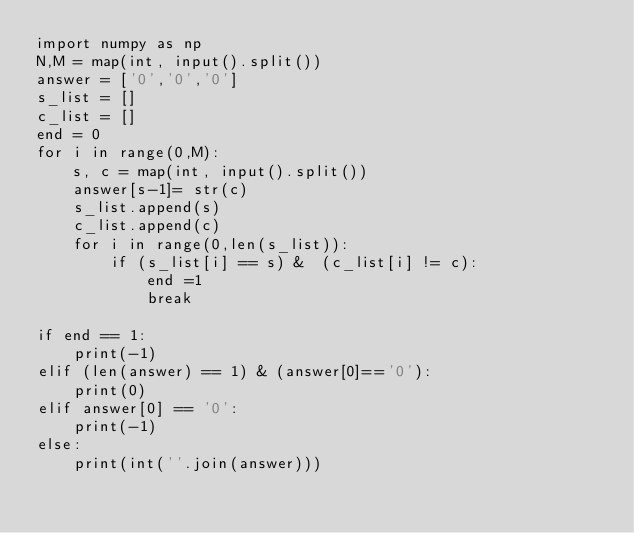<code> <loc_0><loc_0><loc_500><loc_500><_Python_>import numpy as np
N,M = map(int, input().split())
answer = ['0','0','0']
s_list = []
c_list = []
end = 0
for i in range(0,M):
    s, c = map(int, input().split())
    answer[s-1]= str(c)
    s_list.append(s)
    c_list.append(c)
    for i in range(0,len(s_list)):
        if (s_list[i] == s) &  (c_list[i] != c):
            end =1
            break

if end == 1:
    print(-1)
elif (len(answer) == 1) & (answer[0]=='0'): 
    print(0)
elif answer[0] == '0':
    print(-1)
else:
    print(int(''.join(answer)))
</code> 